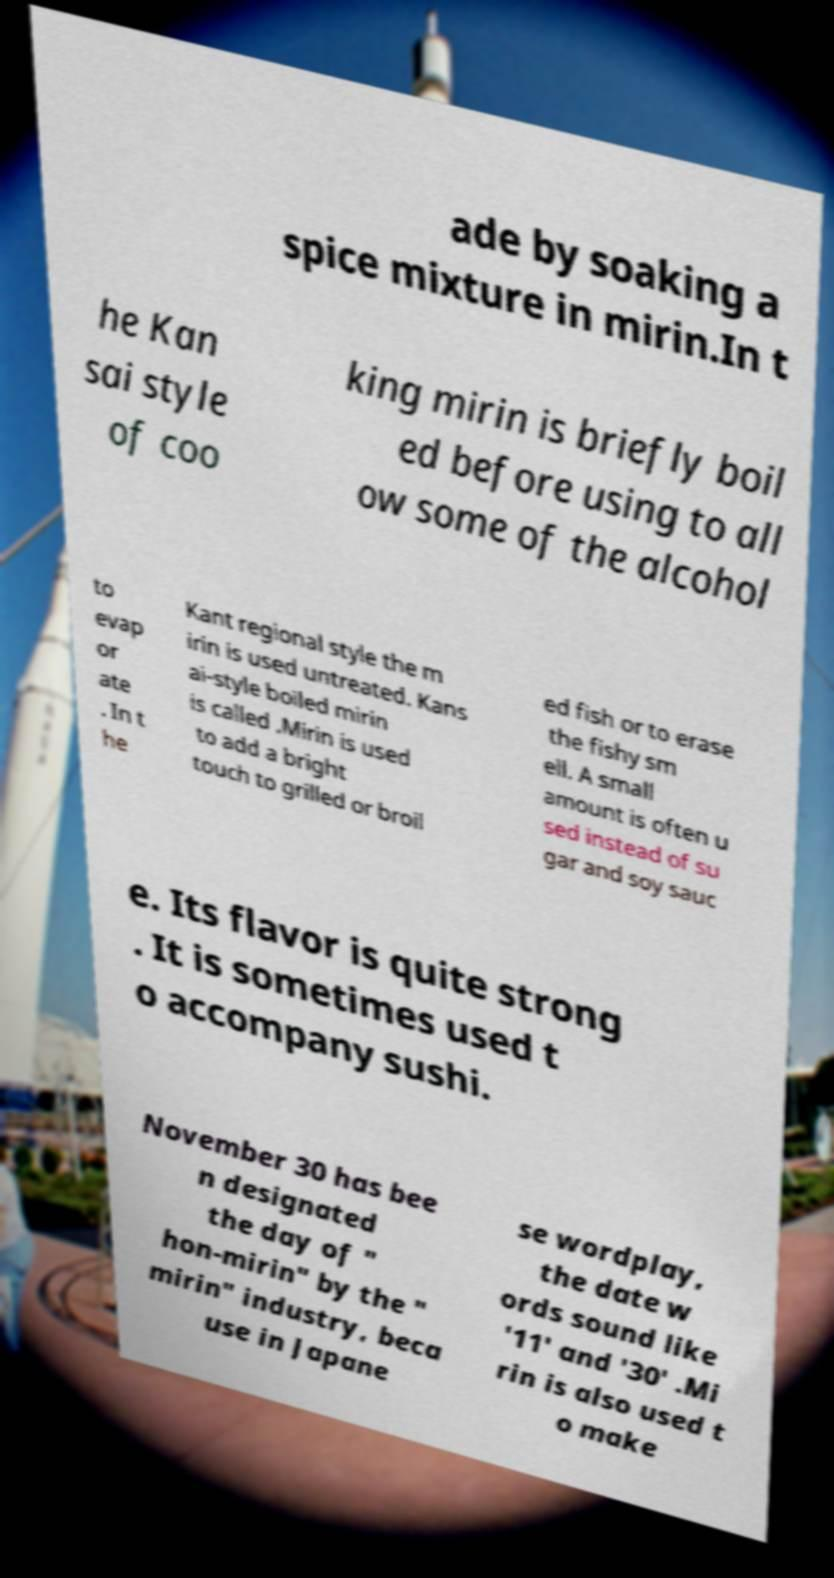Can you read and provide the text displayed in the image?This photo seems to have some interesting text. Can you extract and type it out for me? ade by soaking a spice mixture in mirin.In t he Kan sai style of coo king mirin is briefly boil ed before using to all ow some of the alcohol to evap or ate . In t he Kant regional style the m irin is used untreated. Kans ai-style boiled mirin is called .Mirin is used to add a bright touch to grilled or broil ed fish or to erase the fishy sm ell. A small amount is often u sed instead of su gar and soy sauc e. Its flavor is quite strong . It is sometimes used t o accompany sushi. November 30 has bee n designated the day of " hon-mirin" by the " mirin" industry, beca use in Japane se wordplay, the date w ords sound like '11' and '30' .Mi rin is also used t o make 